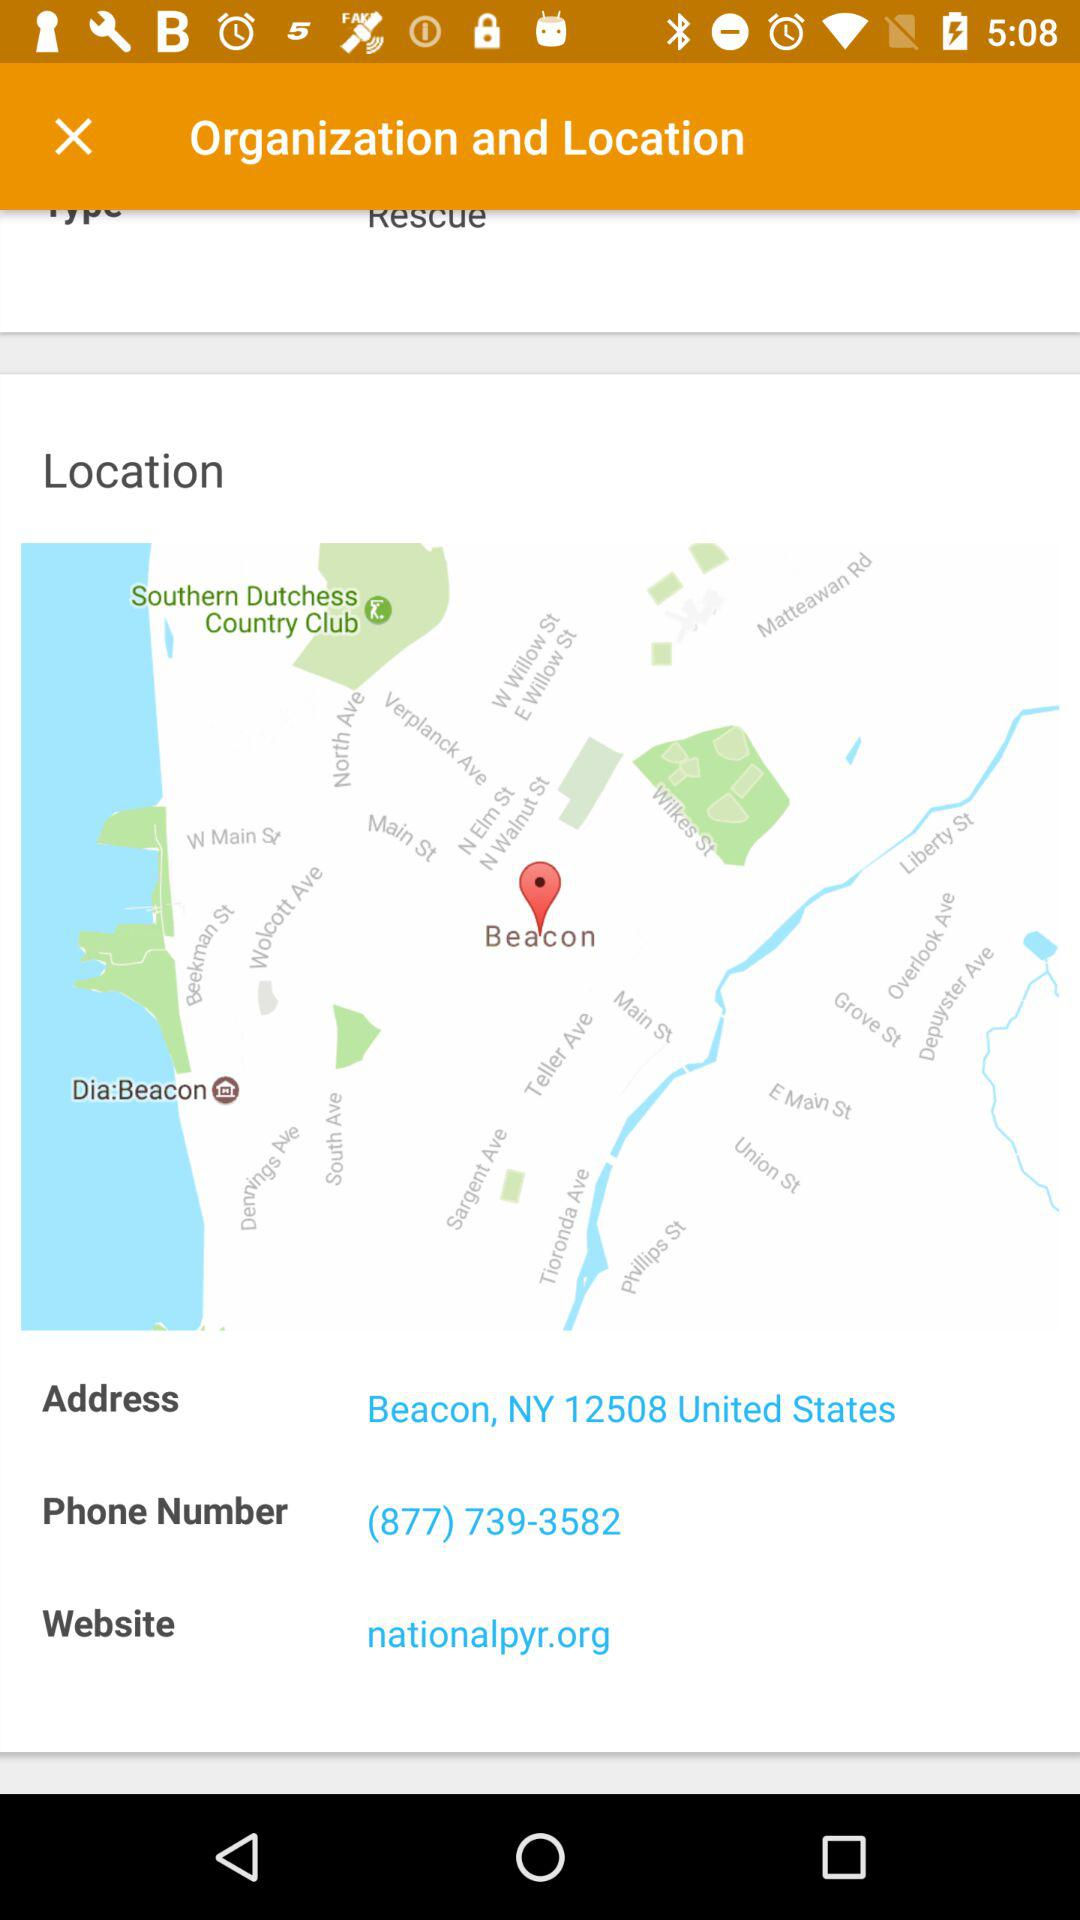How many more contact details are there than organization and location details?
Answer the question using a single word or phrase. 2 